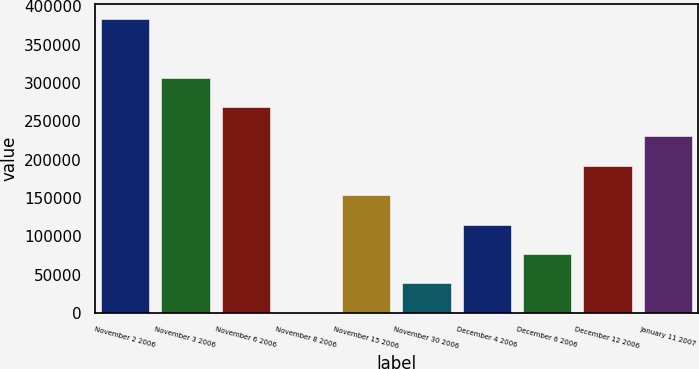Convert chart. <chart><loc_0><loc_0><loc_500><loc_500><bar_chart><fcel>November 2 2006<fcel>November 3 2006<fcel>November 6 2006<fcel>November 8 2006<fcel>November 15 2006<fcel>November 30 2006<fcel>December 4 2006<fcel>December 6 2006<fcel>December 12 2006<fcel>January 11 2007<nl><fcel>383846<fcel>307090<fcel>268712<fcel>66<fcel>153578<fcel>38444<fcel>115200<fcel>76822<fcel>191956<fcel>230334<nl></chart> 